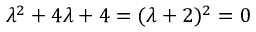<formula> <loc_0><loc_0><loc_500><loc_500>\lambda ^ { 2 } + 4 \lambda + 4 = ( \lambda + 2 ) ^ { 2 } = 0</formula> 